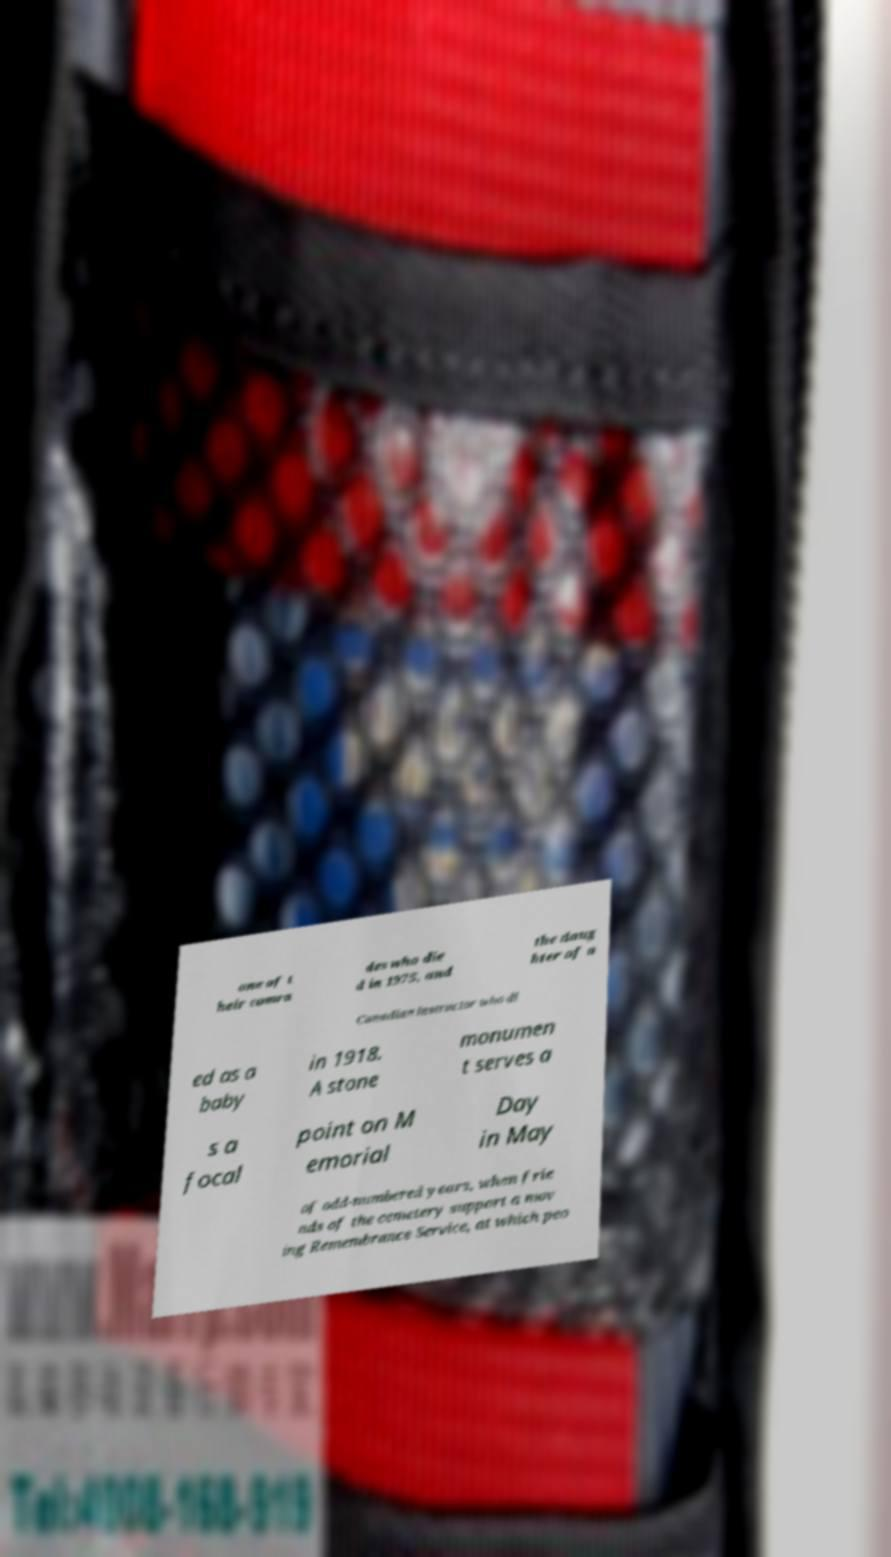What messages or text are displayed in this image? I need them in a readable, typed format. one of t heir comra des who die d in 1975, and the daug hter of a Canadian instructor who di ed as a baby in 1918. A stone monumen t serves a s a focal point on M emorial Day in May of odd-numbered years, when frie nds of the cemetery support a mov ing Remembrance Service, at which peo 